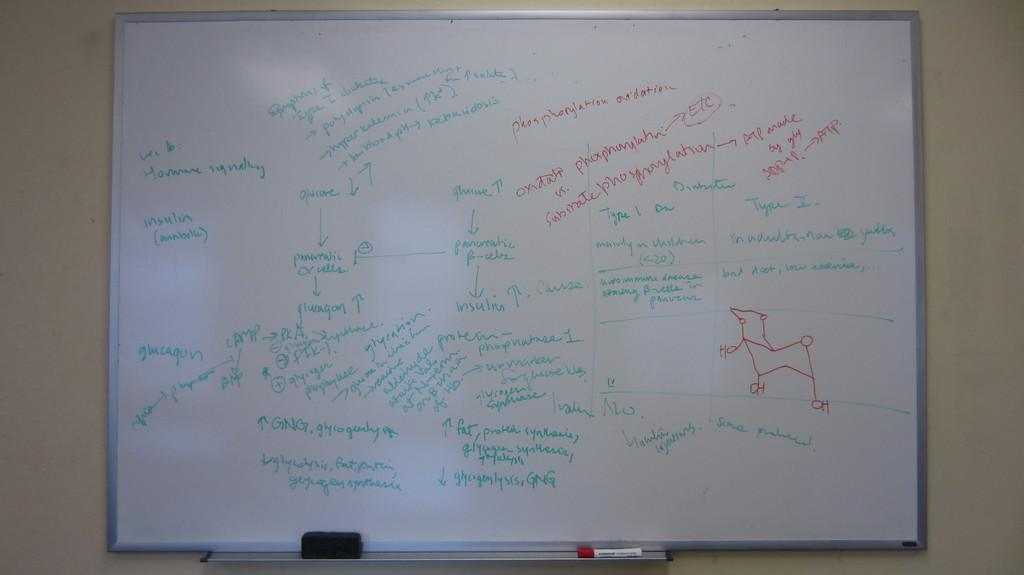<image>
Create a compact narrative representing the image presented. A whiteboard with green and red writing for chemical compounds Ho and Ch. 